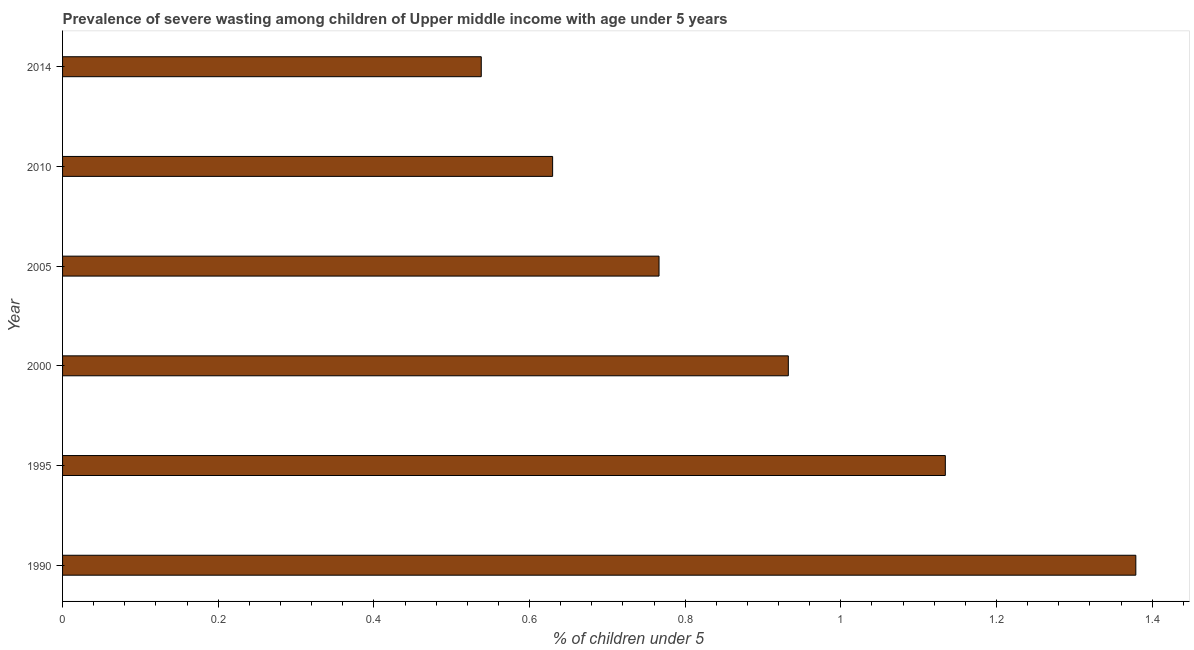What is the title of the graph?
Ensure brevity in your answer.  Prevalence of severe wasting among children of Upper middle income with age under 5 years. What is the label or title of the X-axis?
Provide a succinct answer.  % of children under 5. What is the prevalence of severe wasting in 2000?
Provide a short and direct response. 0.93. Across all years, what is the maximum prevalence of severe wasting?
Keep it short and to the point. 1.38. Across all years, what is the minimum prevalence of severe wasting?
Make the answer very short. 0.54. What is the sum of the prevalence of severe wasting?
Make the answer very short. 5.38. What is the difference between the prevalence of severe wasting in 1990 and 1995?
Offer a terse response. 0.24. What is the average prevalence of severe wasting per year?
Provide a succinct answer. 0.9. What is the median prevalence of severe wasting?
Ensure brevity in your answer.  0.85. In how many years, is the prevalence of severe wasting greater than 1.36 %?
Your answer should be compact. 1. Do a majority of the years between 2000 and 1995 (inclusive) have prevalence of severe wasting greater than 0.12 %?
Your answer should be very brief. No. What is the ratio of the prevalence of severe wasting in 2000 to that in 2010?
Offer a terse response. 1.48. What is the difference between the highest and the second highest prevalence of severe wasting?
Provide a short and direct response. 0.24. What is the difference between the highest and the lowest prevalence of severe wasting?
Give a very brief answer. 0.84. In how many years, is the prevalence of severe wasting greater than the average prevalence of severe wasting taken over all years?
Your answer should be compact. 3. How many bars are there?
Provide a short and direct response. 6. Are all the bars in the graph horizontal?
Your answer should be compact. Yes. How many years are there in the graph?
Keep it short and to the point. 6. What is the difference between two consecutive major ticks on the X-axis?
Provide a short and direct response. 0.2. What is the  % of children under 5 of 1990?
Offer a terse response. 1.38. What is the  % of children under 5 of 1995?
Offer a terse response. 1.13. What is the  % of children under 5 of 2000?
Your answer should be very brief. 0.93. What is the  % of children under 5 in 2005?
Offer a very short reply. 0.77. What is the  % of children under 5 in 2010?
Your response must be concise. 0.63. What is the  % of children under 5 of 2014?
Ensure brevity in your answer.  0.54. What is the difference between the  % of children under 5 in 1990 and 1995?
Your answer should be compact. 0.24. What is the difference between the  % of children under 5 in 1990 and 2000?
Give a very brief answer. 0.45. What is the difference between the  % of children under 5 in 1990 and 2005?
Keep it short and to the point. 0.61. What is the difference between the  % of children under 5 in 1990 and 2010?
Keep it short and to the point. 0.75. What is the difference between the  % of children under 5 in 1990 and 2014?
Give a very brief answer. 0.84. What is the difference between the  % of children under 5 in 1995 and 2000?
Ensure brevity in your answer.  0.2. What is the difference between the  % of children under 5 in 1995 and 2005?
Provide a succinct answer. 0.37. What is the difference between the  % of children under 5 in 1995 and 2010?
Make the answer very short. 0.5. What is the difference between the  % of children under 5 in 1995 and 2014?
Your answer should be compact. 0.6. What is the difference between the  % of children under 5 in 2000 and 2005?
Ensure brevity in your answer.  0.17. What is the difference between the  % of children under 5 in 2000 and 2010?
Make the answer very short. 0.3. What is the difference between the  % of children under 5 in 2000 and 2014?
Give a very brief answer. 0.39. What is the difference between the  % of children under 5 in 2005 and 2010?
Ensure brevity in your answer.  0.14. What is the difference between the  % of children under 5 in 2005 and 2014?
Your response must be concise. 0.23. What is the difference between the  % of children under 5 in 2010 and 2014?
Offer a very short reply. 0.09. What is the ratio of the  % of children under 5 in 1990 to that in 1995?
Keep it short and to the point. 1.22. What is the ratio of the  % of children under 5 in 1990 to that in 2000?
Make the answer very short. 1.48. What is the ratio of the  % of children under 5 in 1990 to that in 2005?
Your answer should be compact. 1.8. What is the ratio of the  % of children under 5 in 1990 to that in 2010?
Provide a succinct answer. 2.19. What is the ratio of the  % of children under 5 in 1990 to that in 2014?
Keep it short and to the point. 2.56. What is the ratio of the  % of children under 5 in 1995 to that in 2000?
Provide a short and direct response. 1.22. What is the ratio of the  % of children under 5 in 1995 to that in 2005?
Your answer should be compact. 1.48. What is the ratio of the  % of children under 5 in 1995 to that in 2010?
Ensure brevity in your answer.  1.8. What is the ratio of the  % of children under 5 in 1995 to that in 2014?
Offer a very short reply. 2.11. What is the ratio of the  % of children under 5 in 2000 to that in 2005?
Your answer should be compact. 1.22. What is the ratio of the  % of children under 5 in 2000 to that in 2010?
Provide a short and direct response. 1.48. What is the ratio of the  % of children under 5 in 2000 to that in 2014?
Keep it short and to the point. 1.73. What is the ratio of the  % of children under 5 in 2005 to that in 2010?
Ensure brevity in your answer.  1.22. What is the ratio of the  % of children under 5 in 2005 to that in 2014?
Keep it short and to the point. 1.43. What is the ratio of the  % of children under 5 in 2010 to that in 2014?
Provide a succinct answer. 1.17. 